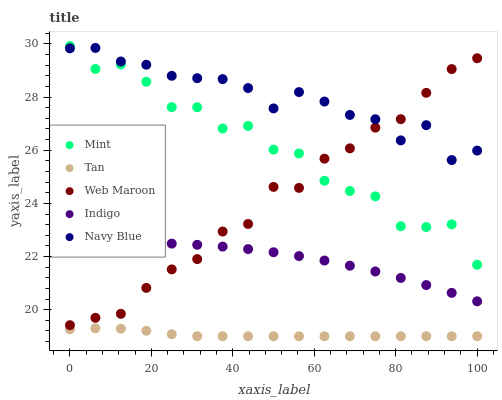Does Tan have the minimum area under the curve?
Answer yes or no. Yes. Does Navy Blue have the maximum area under the curve?
Answer yes or no. Yes. Does Mint have the minimum area under the curve?
Answer yes or no. No. Does Mint have the maximum area under the curve?
Answer yes or no. No. Is Tan the smoothest?
Answer yes or no. Yes. Is Mint the roughest?
Answer yes or no. Yes. Is Mint the smoothest?
Answer yes or no. No. Is Tan the roughest?
Answer yes or no. No. Does Tan have the lowest value?
Answer yes or no. Yes. Does Mint have the lowest value?
Answer yes or no. No. Does Mint have the highest value?
Answer yes or no. Yes. Does Tan have the highest value?
Answer yes or no. No. Is Tan less than Web Maroon?
Answer yes or no. Yes. Is Mint greater than Indigo?
Answer yes or no. Yes. Does Navy Blue intersect Web Maroon?
Answer yes or no. Yes. Is Navy Blue less than Web Maroon?
Answer yes or no. No. Is Navy Blue greater than Web Maroon?
Answer yes or no. No. Does Tan intersect Web Maroon?
Answer yes or no. No. 